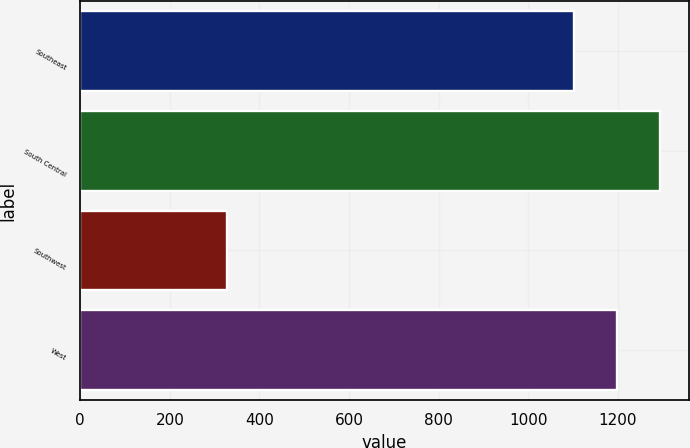Convert chart to OTSL. <chart><loc_0><loc_0><loc_500><loc_500><bar_chart><fcel>Southeast<fcel>South Central<fcel>Southwest<fcel>West<nl><fcel>1101.9<fcel>1292.82<fcel>327.7<fcel>1197.36<nl></chart> 